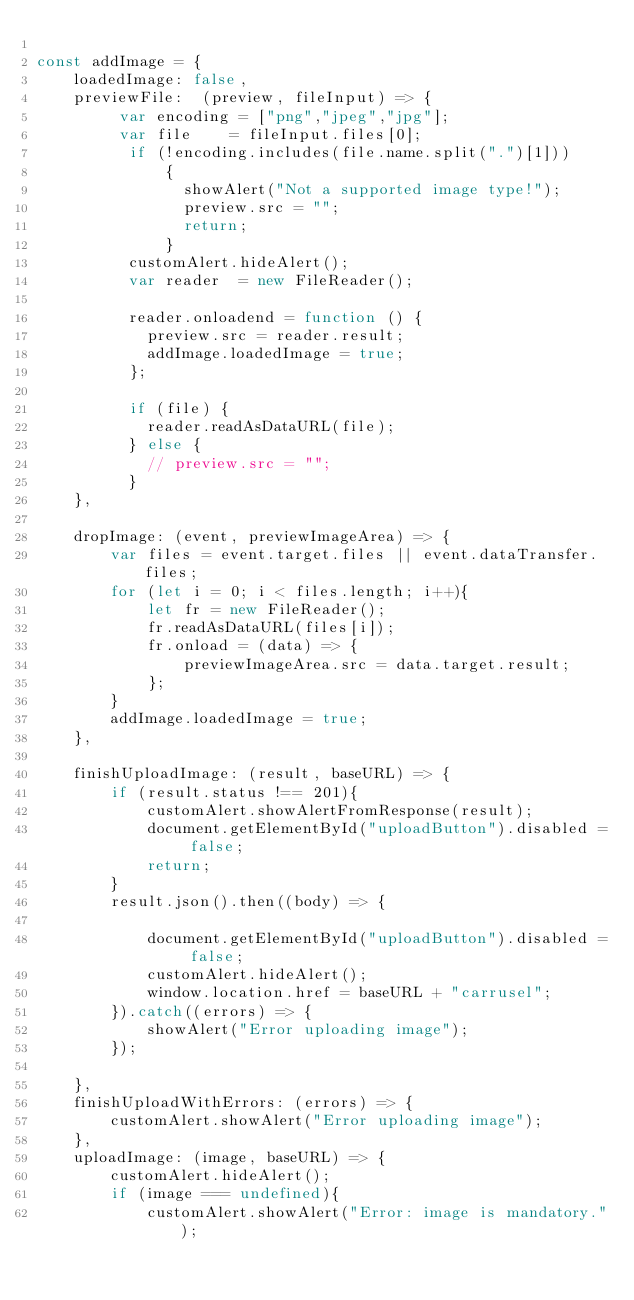<code> <loc_0><loc_0><loc_500><loc_500><_JavaScript_>
const addImage = {
	loadedImage: false,
	previewFile:  (preview, fileInput) => {
		 var encoding = ["png","jpeg","jpg"];
		 var file    = fileInput.files[0];
		  if (!encoding.includes(file.name.split(".")[1]))
			  {
			  	showAlert("Not a supported image type!");
			  	preview.src = "";
			  	return;
			  }
		  customAlert.hideAlert();
		  var reader  = new FileReader();

		  reader.onloadend = function () {
		    preview.src = reader.result;
		    addImage.loadedImage = true;
		  };

		  if (file) {
		    reader.readAsDataURL(file);
		  } else {
		    // preview.src = "";
		  }
	},
	
	dropImage: (event, previewImageArea) => {
		var files = event.target.files || event.dataTransfer.files;
		for (let i = 0; i < files.length; i++){
			let fr = new FileReader();
			fr.readAsDataURL(files[i]);
			fr.onload = (data) => {
				previewImageArea.src = data.target.result;
			};
		}
		addImage.loadedImage = true;
	},
	
	finishUploadImage: (result, baseURL) => {
		if (result.status !== 201){
			customAlert.showAlertFromResponse(result);
			document.getElementById("uploadButton").disabled = false;
			return;
		}
		result.json().then((body) => {
			
			document.getElementById("uploadButton").disabled = false;
			customAlert.hideAlert();
			window.location.href = baseURL + "carrusel";
		}).catch((errors) => {
			showAlert("Error uploading image");
		});
		
	},
	finishUploadWithErrors: (errors) => {
		customAlert.showAlert("Error uploading image");
	},
	uploadImage: (image, baseURL) => {
		customAlert.hideAlert();
		if (image === undefined){
			customAlert.showAlert("Error: image is mandatory.");</code> 